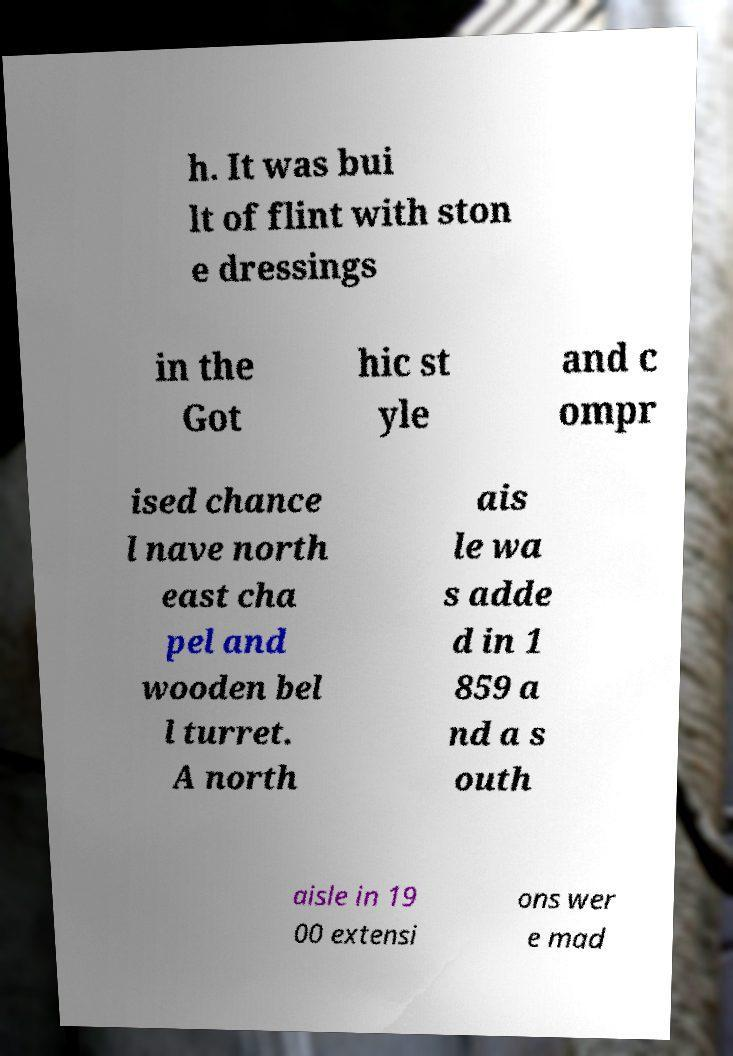I need the written content from this picture converted into text. Can you do that? h. It was bui lt of flint with ston e dressings in the Got hic st yle and c ompr ised chance l nave north east cha pel and wooden bel l turret. A north ais le wa s adde d in 1 859 a nd a s outh aisle in 19 00 extensi ons wer e mad 